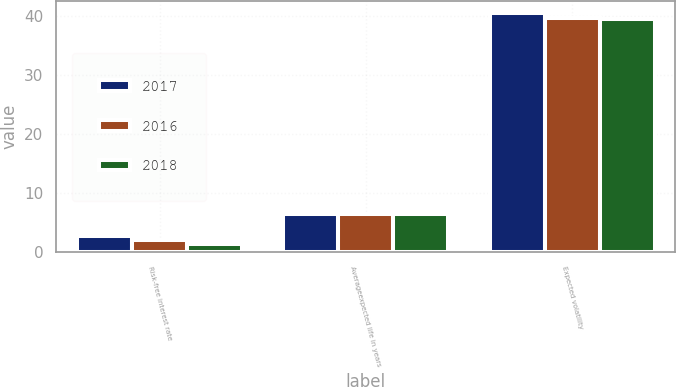<chart> <loc_0><loc_0><loc_500><loc_500><stacked_bar_chart><ecel><fcel>Risk-free interest rate<fcel>Averageexpected life in years<fcel>Expected volatility<nl><fcel>2017<fcel>2.8<fcel>6.5<fcel>40.4<nl><fcel>2016<fcel>2.1<fcel>6.5<fcel>39.6<nl><fcel>2018<fcel>1.4<fcel>6.5<fcel>39.5<nl></chart> 